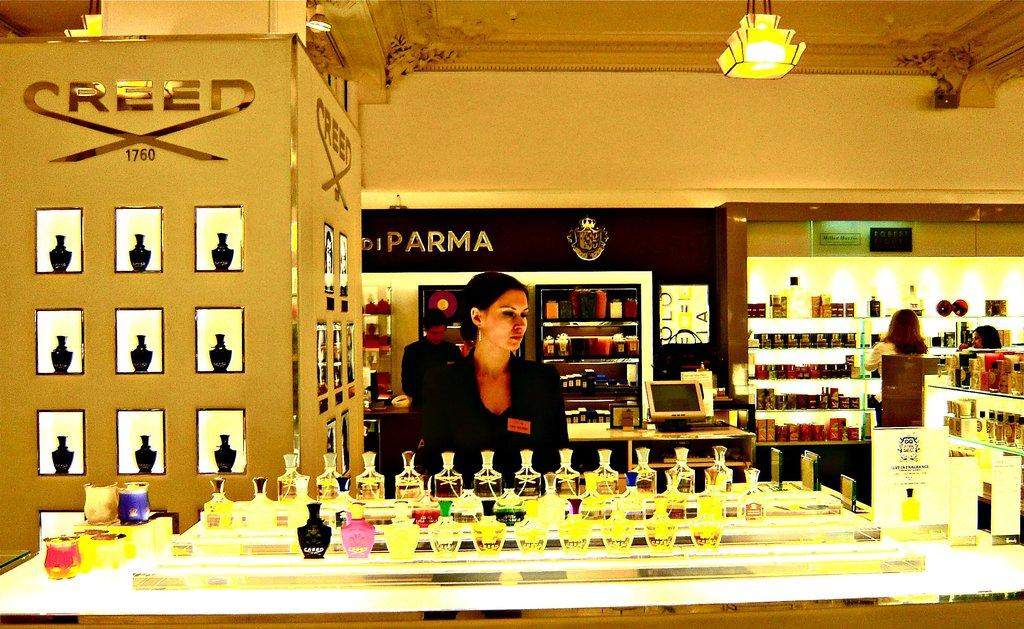Provide a one-sentence caption for the provided image. A woman in a black blazer is standing behind the creed perfume counter. 